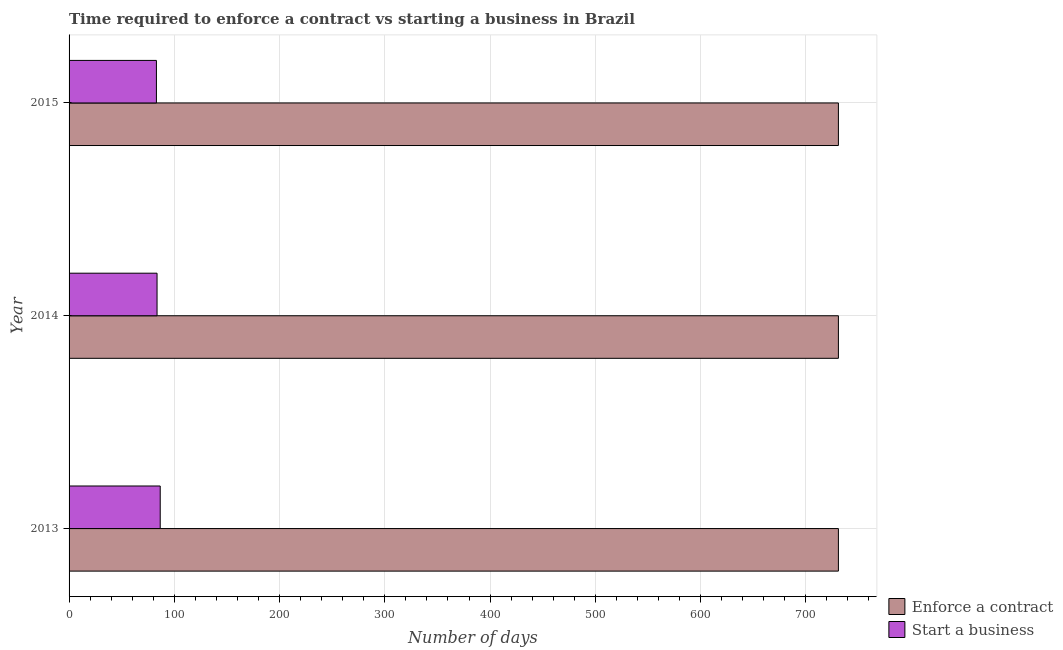How many different coloured bars are there?
Your answer should be compact. 2. Are the number of bars on each tick of the Y-axis equal?
Your response must be concise. Yes. How many bars are there on the 1st tick from the top?
Make the answer very short. 2. How many bars are there on the 2nd tick from the bottom?
Offer a terse response. 2. What is the label of the 2nd group of bars from the top?
Your answer should be compact. 2014. What is the number of days to start a business in 2013?
Keep it short and to the point. 86.6. Across all years, what is the maximum number of days to start a business?
Your answer should be compact. 86.6. Across all years, what is the minimum number of days to enforece a contract?
Ensure brevity in your answer.  731. In which year was the number of days to enforece a contract minimum?
Your answer should be very brief. 2013. What is the total number of days to start a business in the graph?
Give a very brief answer. 253.2. What is the difference between the number of days to start a business in 2013 and that in 2014?
Provide a short and direct response. 3. What is the difference between the number of days to enforece a contract in 2013 and the number of days to start a business in 2014?
Your answer should be compact. 647.4. What is the average number of days to start a business per year?
Your response must be concise. 84.4. In the year 2015, what is the difference between the number of days to start a business and number of days to enforece a contract?
Keep it short and to the point. -648. In how many years, is the number of days to start a business greater than 480 days?
Offer a very short reply. 0. Is the difference between the number of days to enforece a contract in 2013 and 2014 greater than the difference between the number of days to start a business in 2013 and 2014?
Keep it short and to the point. No. What is the difference between the highest and the lowest number of days to enforece a contract?
Provide a succinct answer. 0. What does the 1st bar from the top in 2014 represents?
Provide a short and direct response. Start a business. What does the 2nd bar from the bottom in 2013 represents?
Give a very brief answer. Start a business. What is the difference between two consecutive major ticks on the X-axis?
Your answer should be compact. 100. Does the graph contain any zero values?
Your response must be concise. No. Where does the legend appear in the graph?
Your response must be concise. Bottom right. What is the title of the graph?
Ensure brevity in your answer.  Time required to enforce a contract vs starting a business in Brazil. Does "Stunting" appear as one of the legend labels in the graph?
Make the answer very short. No. What is the label or title of the X-axis?
Offer a terse response. Number of days. What is the Number of days of Enforce a contract in 2013?
Make the answer very short. 731. What is the Number of days of Start a business in 2013?
Offer a terse response. 86.6. What is the Number of days of Enforce a contract in 2014?
Your response must be concise. 731. What is the Number of days of Start a business in 2014?
Keep it short and to the point. 83.6. What is the Number of days in Enforce a contract in 2015?
Offer a terse response. 731. Across all years, what is the maximum Number of days in Enforce a contract?
Your answer should be compact. 731. Across all years, what is the maximum Number of days in Start a business?
Your response must be concise. 86.6. Across all years, what is the minimum Number of days of Enforce a contract?
Your response must be concise. 731. What is the total Number of days of Enforce a contract in the graph?
Your answer should be compact. 2193. What is the total Number of days of Start a business in the graph?
Your answer should be compact. 253.2. What is the difference between the Number of days of Enforce a contract in 2013 and that in 2014?
Make the answer very short. 0. What is the difference between the Number of days of Enforce a contract in 2013 and that in 2015?
Offer a very short reply. 0. What is the difference between the Number of days in Start a business in 2013 and that in 2015?
Make the answer very short. 3.6. What is the difference between the Number of days in Enforce a contract in 2013 and the Number of days in Start a business in 2014?
Offer a terse response. 647.4. What is the difference between the Number of days in Enforce a contract in 2013 and the Number of days in Start a business in 2015?
Your answer should be very brief. 648. What is the difference between the Number of days of Enforce a contract in 2014 and the Number of days of Start a business in 2015?
Your answer should be very brief. 648. What is the average Number of days in Enforce a contract per year?
Provide a succinct answer. 731. What is the average Number of days of Start a business per year?
Your answer should be very brief. 84.4. In the year 2013, what is the difference between the Number of days of Enforce a contract and Number of days of Start a business?
Make the answer very short. 644.4. In the year 2014, what is the difference between the Number of days in Enforce a contract and Number of days in Start a business?
Keep it short and to the point. 647.4. In the year 2015, what is the difference between the Number of days of Enforce a contract and Number of days of Start a business?
Provide a succinct answer. 648. What is the ratio of the Number of days of Enforce a contract in 2013 to that in 2014?
Keep it short and to the point. 1. What is the ratio of the Number of days in Start a business in 2013 to that in 2014?
Give a very brief answer. 1.04. What is the ratio of the Number of days in Enforce a contract in 2013 to that in 2015?
Provide a short and direct response. 1. What is the ratio of the Number of days of Start a business in 2013 to that in 2015?
Ensure brevity in your answer.  1.04. What is the difference between the highest and the second highest Number of days of Enforce a contract?
Offer a terse response. 0. What is the difference between the highest and the second highest Number of days of Start a business?
Ensure brevity in your answer.  3. What is the difference between the highest and the lowest Number of days of Enforce a contract?
Offer a terse response. 0. 